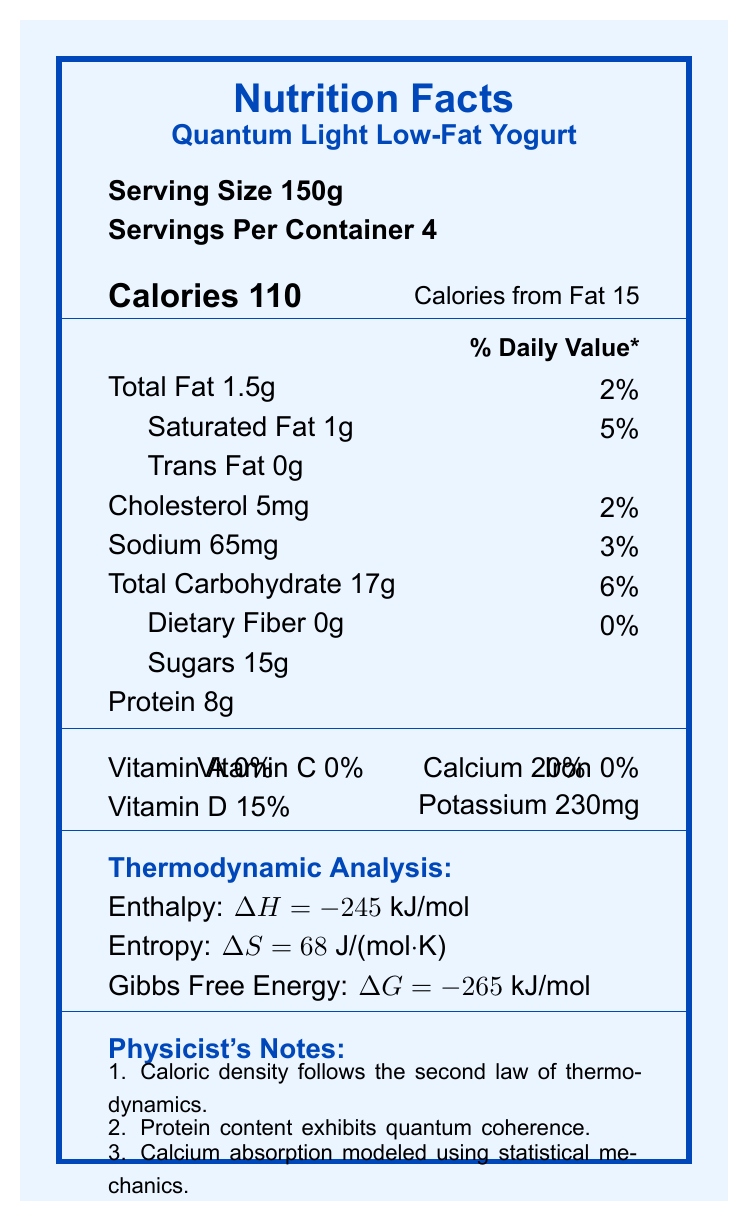what is the serving size? The document specifies "Serving Size 150g" immediately in the serving information section.
Answer: 150g how many servings are in the container? The document specifies "Servings Per Container 4" immediately in the serving information section.
Answer: 4 how many calories are in one serving? The document specifies "Calories 110" in the calorie information section.
Answer: 110 what is the amount of protein per serving? The document specifies "Protein 8g" in the nutrient information section.
Answer: 8g what is the percentage of daily value for calcium? The document specifies "Calcium 20%" in the vitamin information section.
Answer: 20% what is the amount of total fat per serving? A. 1g B. 1.5g C. 2g D. 0g The document specifies "Total Fat 1.5g" in the nutrient information section.
Answer: B what is the amount of sodium in one serving? A. 30mg B. 65mg C. 120mg D. 40mg The document specifies "Sodium 65mg" in the nutrient information section.
Answer: B does this yogurt contain trans fat? The document specifies "Trans Fat 0g" in the nutrient information section, indicating it does not contain trans fat.
Answer: No is the yogurt high in vitamin A? The document specifies "Vitamin A 0%" in the vitamin information section, indicating it has no vitamin A.
Answer: No summarize the main nutritional contents of the yogurt. The summary covers the main nutritional facts given in the document, including calories, macronutrients, vitamins, and thermodynamic properties.
Answer: Quantum Light Low-Fat Yogurt provides 110 calories per 150g serving. It contains 1.5g of total fat, 17g of carbohydrates, 15g of sugars, 8g of protein, key vitamins such as calcium (20%), and vitamin D (15%). It also has thermodynamic properties related to enthalpy (-245 kJ/mol), entropy (68 J/(mol·K)), and Gibbs free energy (-265 kJ/mol). what is the facility that processes the yogurt also used to process? The document specifies that the yogurt is produced in a facility that processes soy and tree nuts in the allergen information section.
Answer: Produced in a facility that also processes soy and tree nuts. how does the protein content of the yogurt exhibit quantum effects? According to the physicist's notes, "Protein content exhibits quantum coherence", indicating potential quantum effects.
Answer: Protein content exhibits quantum coherence. what temperature should the yogurt be stored at? The document specifies "Keep refrigerated at or below 40°F (4°C)" in the storage instructions.
Answer: Refrigerated at or below 40°F (4°C). what is the manufacturing location of this yogurt? The document specifies "Quantum Dairy Labs, Berkeley, CA 94720, USA" in the manufacturing location section.
Answer: Berkeley, CA 94720, USA what additional insights can be derived from the thermodynamic analysis provided? The document provides enthalpy, entropy, and Gibbs free energy values, but it does not explain how these values were measured or their detailed implications.
Answer: Not enough information 